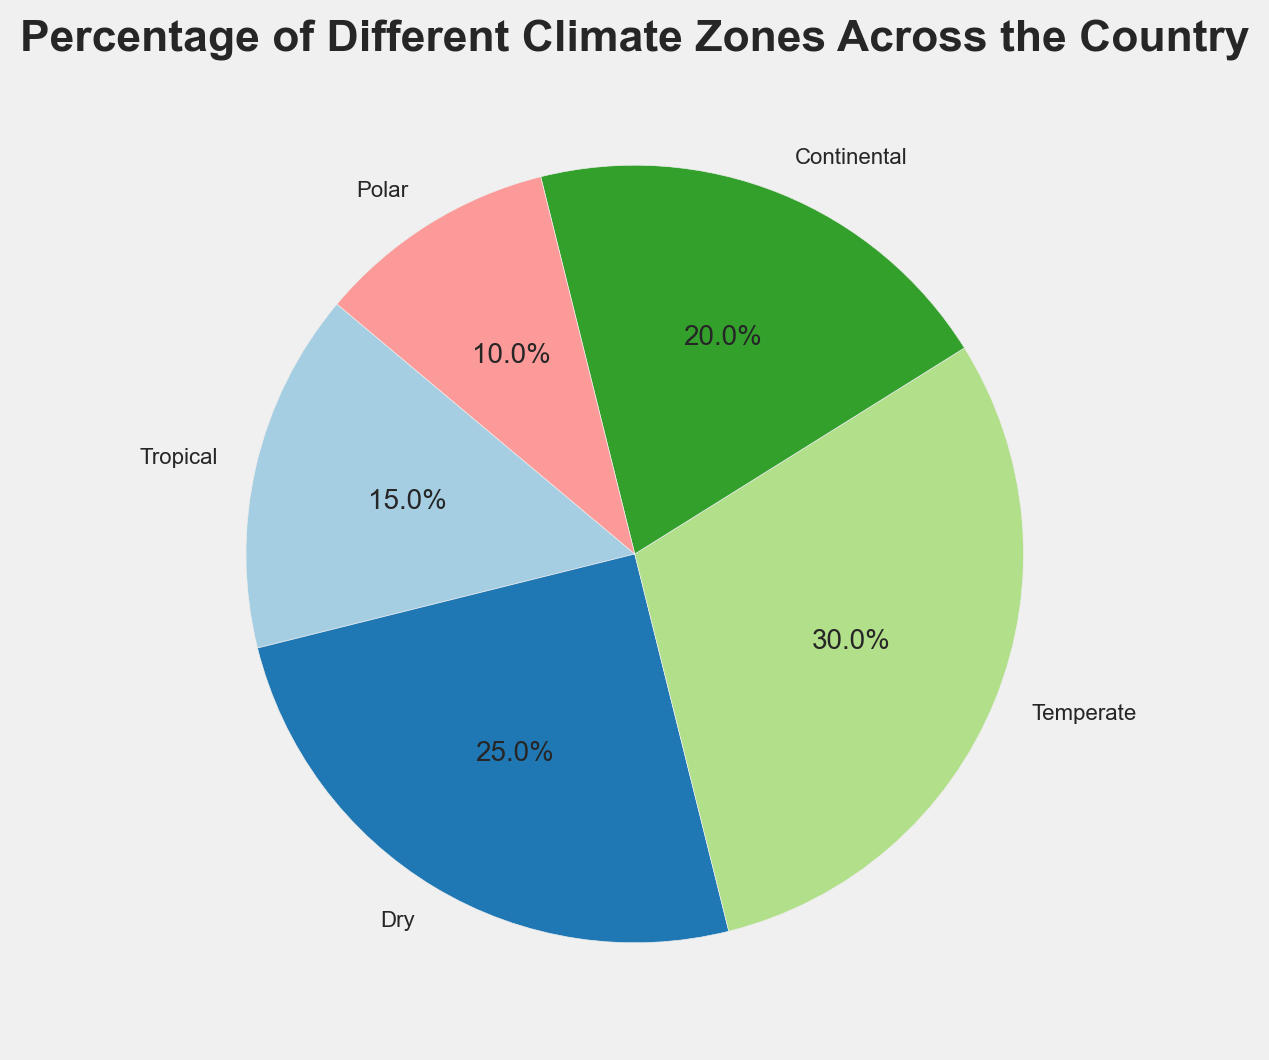What percentage of the country is covered by the Temperate climate zone? Looking at the pie chart, locate the segment for the Temperate climate zone and read the percentage value.
Answer: 30% Which climate zone covers the largest percentage of the country? Examine the pie chart and identify which segment has the largest area. The label associated with this segment shows it is the Dry climate zone.
Answer: Dry How much larger is the Temperate zone compared to the Polar zone? Find the percentages for both the Temperate and Polar zones (30% and 10%, respectively) and calculate the difference: 30% - 10% = 20%.
Answer: 20% Which climate zones cover more than 20% of the country? Look at the pie chart segments to identify any that are more than 20%. Both the Dry (25%) and Temperate (30%) zones meet this criterion.
Answer: Dry, Temperate Are there any climate zones that cover exactly 20% of the country? Check the pie chart segments for a label showing 20%. The Continental zone is labeled as 20%.
Answer: Continental How do the combined percentages of the Tropical and Polar zones compare to the Temperate zone? The Tropical zone is 15% and the Polar zone is 10%. Add these together to get 25%. The Temperate zone is 30%, so the combined percentage of Tropical and Polar zones (25%) is less than the Temperate zone (30%).
Answer: Less than What fraction of the country is not covered by the Continental zone? The Continental zone covers 20%. Subtract this from 100% to find the fraction not covered: 100% - 20% = 80%.
Answer: 80% What color represents the Dry climate zone in the pie chart? Look at the pie chart and identify the color of the segment labeled as the Dry zone. Note the color used for this segment; it appears to be a shade of light brown or beige.
Answer: Light brown/beige Which climate zone has the smallest percentage coverage? Identify the segment with the smallest area in the pie chart. The Polar zone is the smallest with 10%.
Answer: Polar 